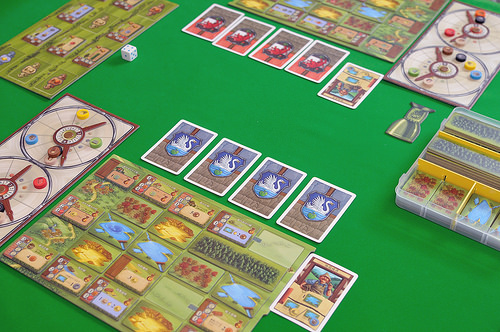<image>
Can you confirm if the cards is under the card? No. The cards is not positioned under the card. The vertical relationship between these objects is different. 